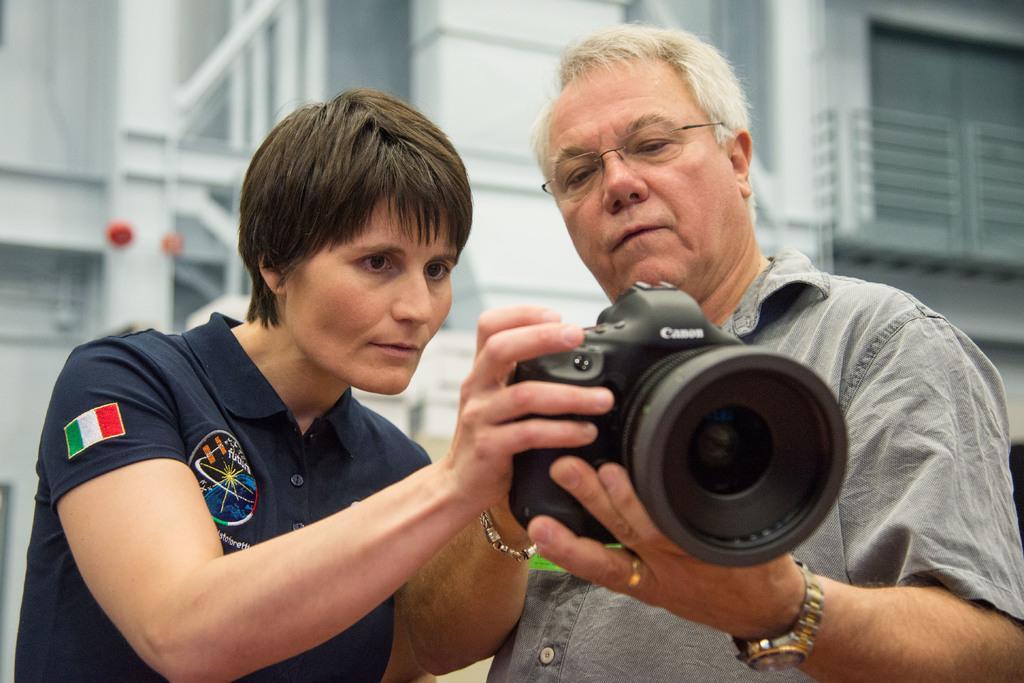Please provide a concise description of this image. In this image there is a person with grey shirt is holding camera with his both hands and there is an other person with blue shirt, he is holding camera with his right hand and looking into the camera. At the back there is a building. 